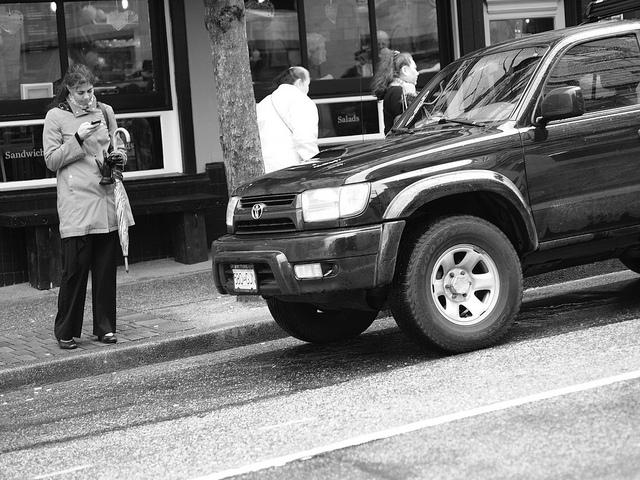What make of car is this?
Answer briefly. Toyota. What is in the woman's left hand?
Be succinct. Umbrella. Is the woman looking at the cell phone aware of the car in front of her?
Be succinct. No. What is the license plate number of the parked car?
Short answer required. Unknown. 